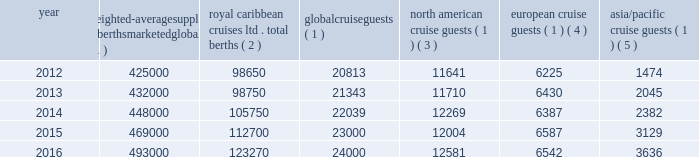The table details the growth in global weighted average berths and the global , north american , european and asia/pacific cruise guests over the past five years ( in thousands , except berth data ) : weighted- average supply of berths marketed globally ( 1 ) caribbean cruises ltd .
Total berths ( 2 ) global cruise guests ( 1 ) american cruise guests ( 1 ) ( 3 ) european cruise guests ( 1 ) ( 4 ) asia/pacific cruise guests ( 1 ) ( 5 ) .
_______________________________________________________________________________ ( 1 ) source : our estimates of the number of global cruise guests and the weighted-average supply of berths marketed globally are based on a combination of data that we obtain from various publicly available cruise industry trade information sources .
We use data obtained from seatrade insider , cruise industry news and company press releases to estimate weighted-average supply of berths and clia and g.p .
Wild to estimate cruise guest information .
In addition , our estimates incorporate our own statistical analysis utilizing the same publicly available cruise industry data as a base .
( 2 ) total berths include our berths related to our global brands and partner brands .
( 3 ) our estimates include the united states and canada .
( 4 ) our estimates include european countries relevant to the industry ( e.g. , nordics , germany , france , italy , spain and the united kingdom ) .
( 5 ) our estimates include the southeast asia ( e.g. , singapore , thailand and the philippines ) , east asia ( e.g. , china and japan ) , south asia ( e.g. , india and pakistan ) and oceanian ( e.g. , australia and fiji islands ) regions .
North america the majority of industry cruise guests are sourced from north america , which represented approximately 52% ( 52 % ) of global cruise guests in 2016 .
The compound annual growth rate in cruise guests sourced from this market was approximately 2% ( 2 % ) from 2012 to 2016 .
Europe industry cruise guests sourced from europe represented approximately 27% ( 27 % ) of global cruise guests in 2016 .
The compound annual growth rate in cruise guests sourced from this market was approximately 1% ( 1 % ) from 2012 to 2016 .
Asia/pacific industry cruise guests sourced from the asia/pacific region represented approximately 15% ( 15 % ) of global cruise guests in 2016 .
The compound annual growth rate in cruise guests sourced from this market was approximately 25% ( 25 % ) from 2012 to 2016 .
The asia/pacific region is experiencing the highest growth rate of the major regions , although it will continue to represent a relatively small sector compared to north america .
Competition we compete with a number of cruise lines .
Our principal competitors are carnival corporation & plc , which owns , among others , aida cruises , carnival cruise line , costa cruises , cunard line , holland america line , p&o cruises , princess cruises and seabourn ; disney cruise line ; msc cruises ; and norwegian cruise line holdings ltd , which owns norwegian cruise line , oceania cruises and regent seven seas cruises .
Cruise lines compete with .
What was the percentage increase of the weighted-average supply of berths marketed globally fom 2012 to 2016? 
Computations: ((493000 - 425000) / 425000)
Answer: 0.16. The table details the growth in global weighted average berths and the global , north american , european and asia/pacific cruise guests over the past five years ( in thousands , except berth data ) : weighted- average supply of berths marketed globally ( 1 ) caribbean cruises ltd .
Total berths ( 2 ) global cruise guests ( 1 ) american cruise guests ( 1 ) ( 3 ) european cruise guests ( 1 ) ( 4 ) asia/pacific cruise guests ( 1 ) ( 5 ) .
_______________________________________________________________________________ ( 1 ) source : our estimates of the number of global cruise guests and the weighted-average supply of berths marketed globally are based on a combination of data that we obtain from various publicly available cruise industry trade information sources .
We use data obtained from seatrade insider , cruise industry news and company press releases to estimate weighted-average supply of berths and clia and g.p .
Wild to estimate cruise guest information .
In addition , our estimates incorporate our own statistical analysis utilizing the same publicly available cruise industry data as a base .
( 2 ) total berths include our berths related to our global brands and partner brands .
( 3 ) our estimates include the united states and canada .
( 4 ) our estimates include european countries relevant to the industry ( e.g. , nordics , germany , france , italy , spain and the united kingdom ) .
( 5 ) our estimates include the southeast asia ( e.g. , singapore , thailand and the philippines ) , east asia ( e.g. , china and japan ) , south asia ( e.g. , india and pakistan ) and oceanian ( e.g. , australia and fiji islands ) regions .
North america the majority of industry cruise guests are sourced from north america , which represented approximately 52% ( 52 % ) of global cruise guests in 2016 .
The compound annual growth rate in cruise guests sourced from this market was approximately 2% ( 2 % ) from 2012 to 2016 .
Europe industry cruise guests sourced from europe represented approximately 27% ( 27 % ) of global cruise guests in 2016 .
The compound annual growth rate in cruise guests sourced from this market was approximately 1% ( 1 % ) from 2012 to 2016 .
Asia/pacific industry cruise guests sourced from the asia/pacific region represented approximately 15% ( 15 % ) of global cruise guests in 2016 .
The compound annual growth rate in cruise guests sourced from this market was approximately 25% ( 25 % ) from 2012 to 2016 .
The asia/pacific region is experiencing the highest growth rate of the major regions , although it will continue to represent a relatively small sector compared to north america .
Competition we compete with a number of cruise lines .
Our principal competitors are carnival corporation & plc , which owns , among others , aida cruises , carnival cruise line , costa cruises , cunard line , holland america line , p&o cruises , princess cruises and seabourn ; disney cruise line ; msc cruises ; and norwegian cruise line holdings ltd , which owns norwegian cruise line , oceania cruises and regent seven seas cruises .
Cruise lines compete with .
In 2012 what was the percentage of the weighted-average supply of berths marketed globally belonged to the royal caribbean cruises? 
Computations: (98650 / 425000)
Answer: 0.23212. 